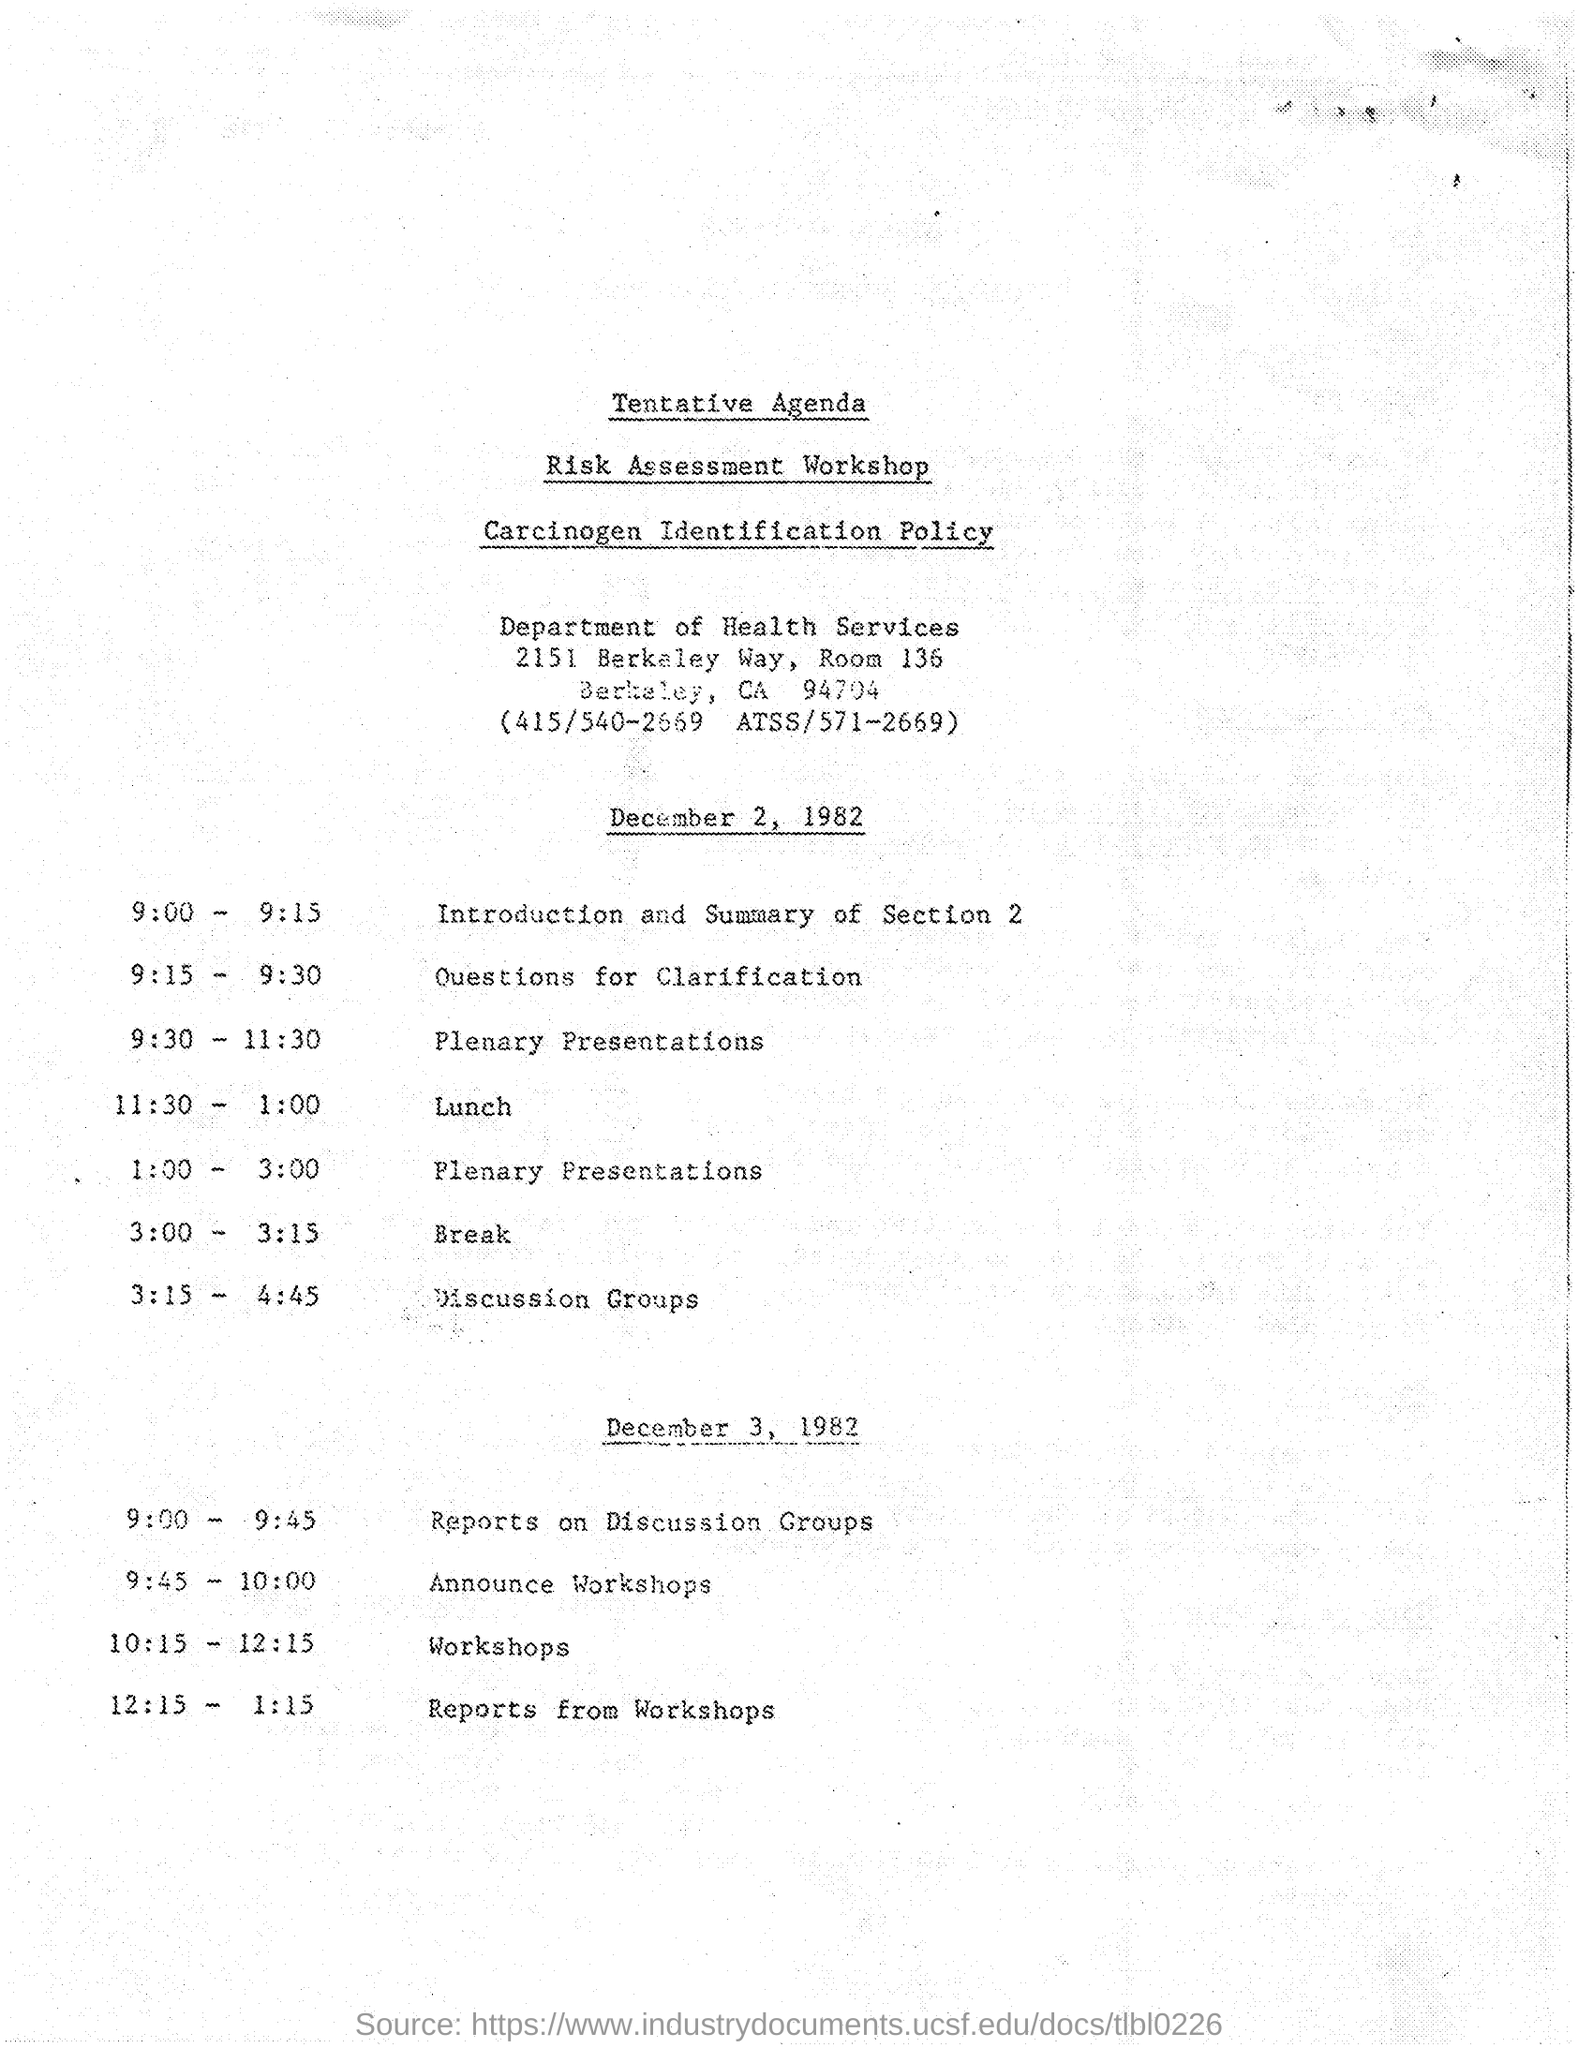Which department is the workshop related to?
Your response must be concise. Department of Health Services. Which programme is scheduled at 9:15 to 9:30?
Ensure brevity in your answer.  Questions for Clarification. 